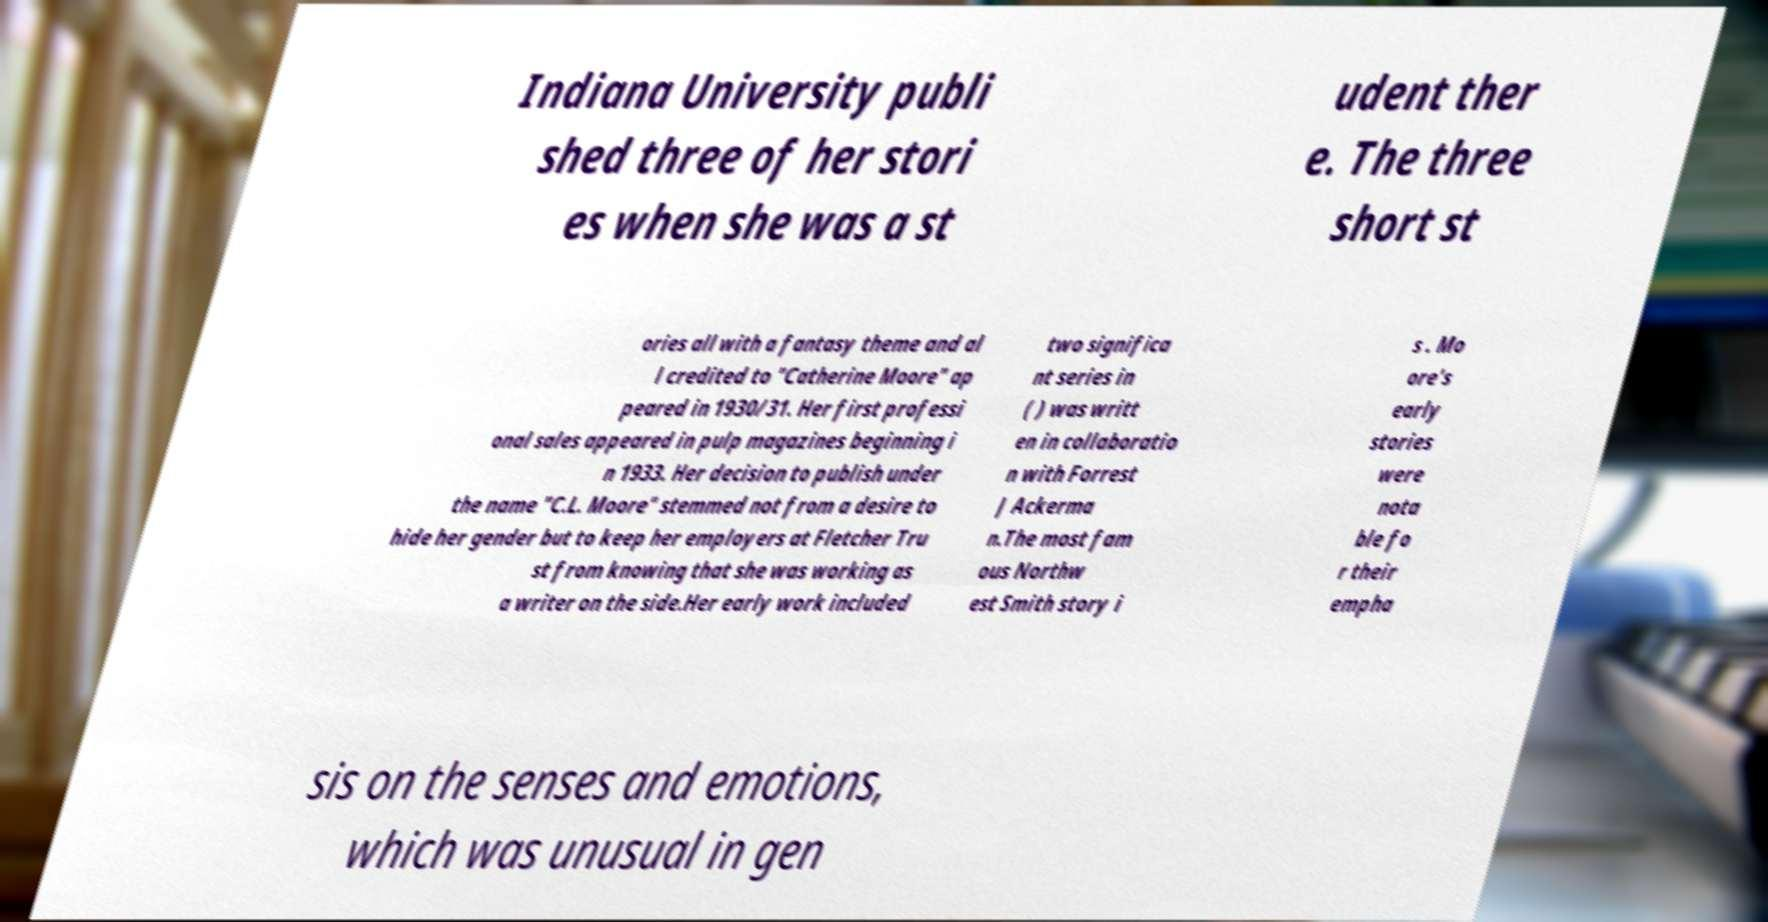Can you accurately transcribe the text from the provided image for me? Indiana University publi shed three of her stori es when she was a st udent ther e. The three short st ories all with a fantasy theme and al l credited to "Catherine Moore" ap peared in 1930/31. Her first professi onal sales appeared in pulp magazines beginning i n 1933. Her decision to publish under the name "C.L. Moore" stemmed not from a desire to hide her gender but to keep her employers at Fletcher Tru st from knowing that she was working as a writer on the side.Her early work included two significa nt series in ( ) was writt en in collaboratio n with Forrest J Ackerma n.The most fam ous Northw est Smith story i s . Mo ore's early stories were nota ble fo r their empha sis on the senses and emotions, which was unusual in gen 